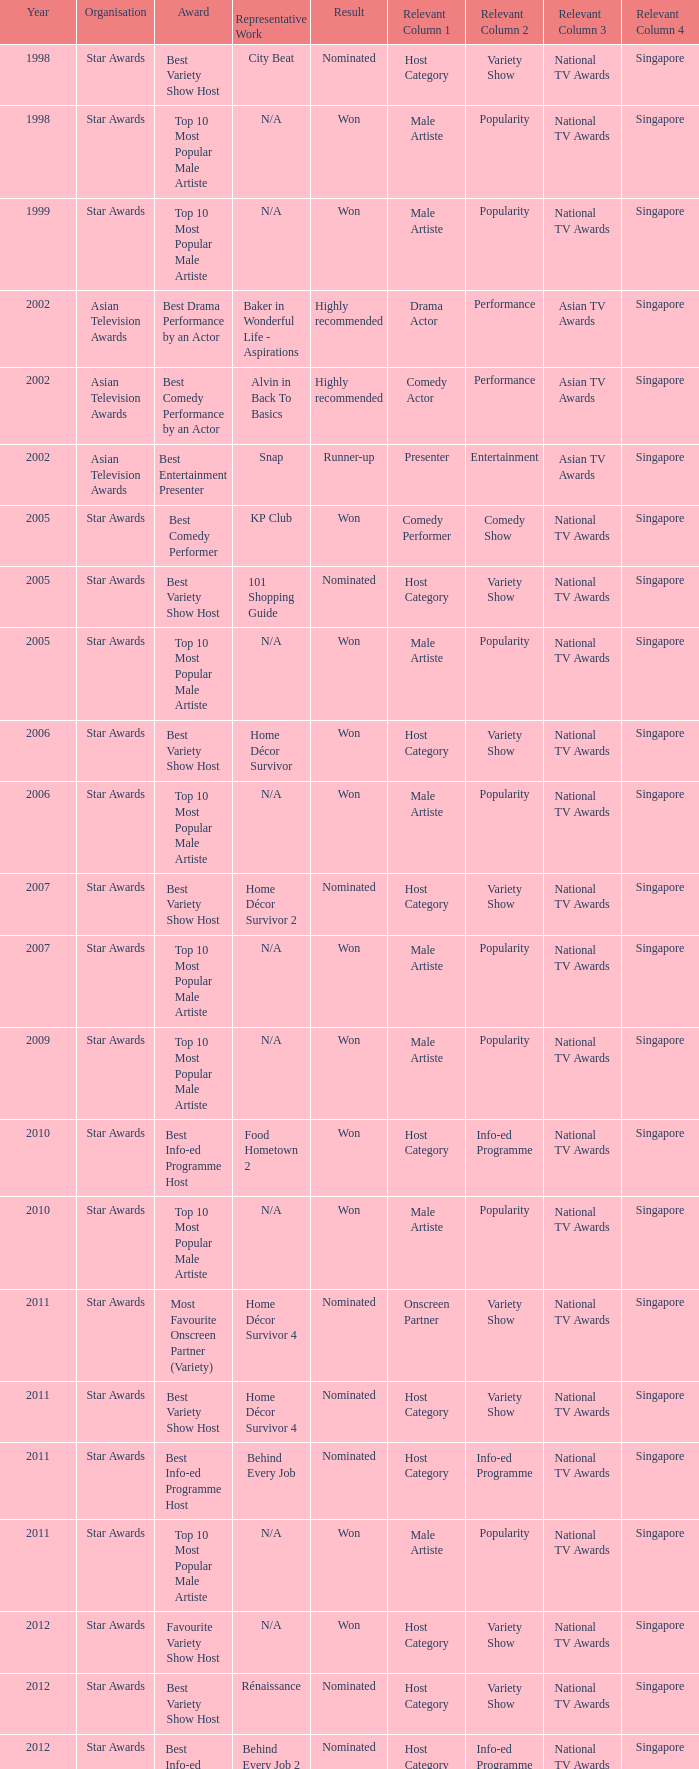What is the name of the award in a year more than 2005, and the Result of nominated? Best Variety Show Host, Most Favourite Onscreen Partner (Variety), Best Variety Show Host, Best Info-ed Programme Host, Best Variety Show Host, Best Info-ed Programme Host, Best Info-Ed Programme Host, Best Variety Show Host. 